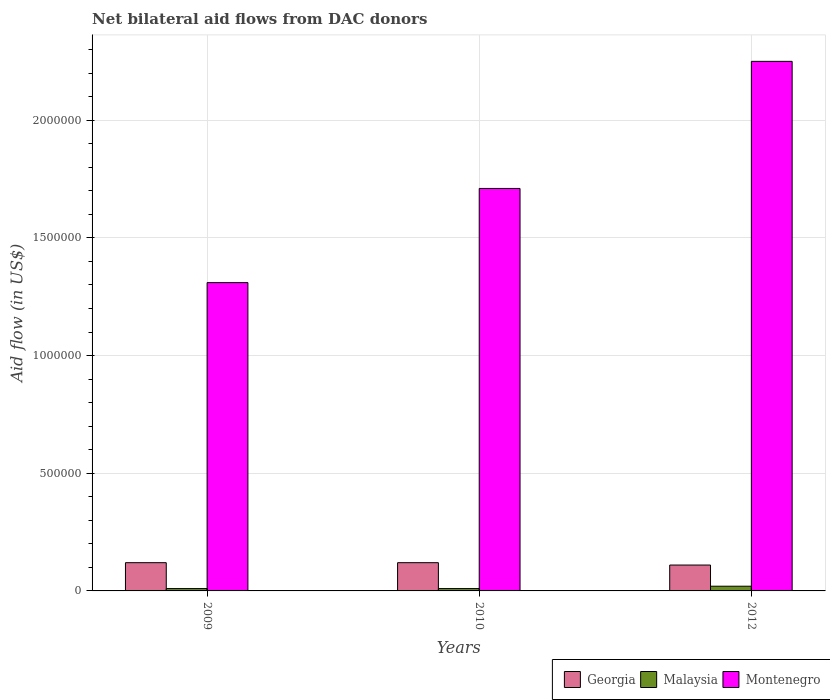How many different coloured bars are there?
Your answer should be very brief. 3. How many bars are there on the 3rd tick from the right?
Provide a succinct answer. 3. In how many cases, is the number of bars for a given year not equal to the number of legend labels?
Your response must be concise. 0. What is the net bilateral aid flow in Montenegro in 2009?
Your response must be concise. 1.31e+06. Across all years, what is the maximum net bilateral aid flow in Georgia?
Offer a very short reply. 1.20e+05. Across all years, what is the minimum net bilateral aid flow in Montenegro?
Your answer should be very brief. 1.31e+06. In which year was the net bilateral aid flow in Georgia maximum?
Offer a very short reply. 2009. In which year was the net bilateral aid flow in Georgia minimum?
Provide a succinct answer. 2012. What is the total net bilateral aid flow in Montenegro in the graph?
Provide a short and direct response. 5.27e+06. What is the difference between the net bilateral aid flow in Malaysia in 2009 and that in 2012?
Offer a terse response. -10000. What is the difference between the net bilateral aid flow in Georgia in 2010 and the net bilateral aid flow in Malaysia in 2012?
Provide a succinct answer. 1.00e+05. What is the average net bilateral aid flow in Malaysia per year?
Keep it short and to the point. 1.33e+04. In the year 2009, what is the difference between the net bilateral aid flow in Montenegro and net bilateral aid flow in Malaysia?
Your answer should be compact. 1.30e+06. In how many years, is the net bilateral aid flow in Georgia greater than 1200000 US$?
Offer a very short reply. 0. What is the ratio of the net bilateral aid flow in Malaysia in 2009 to that in 2012?
Your answer should be compact. 0.5. Is the difference between the net bilateral aid flow in Montenegro in 2009 and 2012 greater than the difference between the net bilateral aid flow in Malaysia in 2009 and 2012?
Your answer should be compact. No. What is the difference between the highest and the second highest net bilateral aid flow in Georgia?
Provide a succinct answer. 0. What is the difference between the highest and the lowest net bilateral aid flow in Georgia?
Provide a succinct answer. 10000. In how many years, is the net bilateral aid flow in Montenegro greater than the average net bilateral aid flow in Montenegro taken over all years?
Offer a terse response. 1. Is the sum of the net bilateral aid flow in Georgia in 2009 and 2012 greater than the maximum net bilateral aid flow in Malaysia across all years?
Keep it short and to the point. Yes. What does the 1st bar from the left in 2012 represents?
Offer a very short reply. Georgia. What does the 2nd bar from the right in 2010 represents?
Ensure brevity in your answer.  Malaysia. Is it the case that in every year, the sum of the net bilateral aid flow in Georgia and net bilateral aid flow in Montenegro is greater than the net bilateral aid flow in Malaysia?
Ensure brevity in your answer.  Yes. Are all the bars in the graph horizontal?
Give a very brief answer. No. Are the values on the major ticks of Y-axis written in scientific E-notation?
Keep it short and to the point. No. Does the graph contain any zero values?
Keep it short and to the point. No. Does the graph contain grids?
Your answer should be compact. Yes. Where does the legend appear in the graph?
Offer a very short reply. Bottom right. How are the legend labels stacked?
Keep it short and to the point. Horizontal. What is the title of the graph?
Offer a terse response. Net bilateral aid flows from DAC donors. Does "Europe(all income levels)" appear as one of the legend labels in the graph?
Offer a terse response. No. What is the label or title of the Y-axis?
Ensure brevity in your answer.  Aid flow (in US$). What is the Aid flow (in US$) in Malaysia in 2009?
Give a very brief answer. 10000. What is the Aid flow (in US$) in Montenegro in 2009?
Offer a terse response. 1.31e+06. What is the Aid flow (in US$) in Malaysia in 2010?
Give a very brief answer. 10000. What is the Aid flow (in US$) of Montenegro in 2010?
Provide a short and direct response. 1.71e+06. What is the Aid flow (in US$) in Montenegro in 2012?
Your response must be concise. 2.25e+06. Across all years, what is the maximum Aid flow (in US$) of Georgia?
Ensure brevity in your answer.  1.20e+05. Across all years, what is the maximum Aid flow (in US$) in Malaysia?
Your answer should be very brief. 2.00e+04. Across all years, what is the maximum Aid flow (in US$) of Montenegro?
Provide a succinct answer. 2.25e+06. Across all years, what is the minimum Aid flow (in US$) in Georgia?
Make the answer very short. 1.10e+05. Across all years, what is the minimum Aid flow (in US$) in Malaysia?
Your response must be concise. 10000. Across all years, what is the minimum Aid flow (in US$) of Montenegro?
Your answer should be very brief. 1.31e+06. What is the total Aid flow (in US$) in Montenegro in the graph?
Ensure brevity in your answer.  5.27e+06. What is the difference between the Aid flow (in US$) in Malaysia in 2009 and that in 2010?
Ensure brevity in your answer.  0. What is the difference between the Aid flow (in US$) in Montenegro in 2009 and that in 2010?
Your response must be concise. -4.00e+05. What is the difference between the Aid flow (in US$) of Georgia in 2009 and that in 2012?
Offer a terse response. 10000. What is the difference between the Aid flow (in US$) in Malaysia in 2009 and that in 2012?
Provide a succinct answer. -10000. What is the difference between the Aid flow (in US$) in Montenegro in 2009 and that in 2012?
Offer a terse response. -9.40e+05. What is the difference between the Aid flow (in US$) of Georgia in 2010 and that in 2012?
Ensure brevity in your answer.  10000. What is the difference between the Aid flow (in US$) in Montenegro in 2010 and that in 2012?
Keep it short and to the point. -5.40e+05. What is the difference between the Aid flow (in US$) of Georgia in 2009 and the Aid flow (in US$) of Malaysia in 2010?
Offer a very short reply. 1.10e+05. What is the difference between the Aid flow (in US$) in Georgia in 2009 and the Aid flow (in US$) in Montenegro in 2010?
Offer a very short reply. -1.59e+06. What is the difference between the Aid flow (in US$) in Malaysia in 2009 and the Aid flow (in US$) in Montenegro in 2010?
Offer a very short reply. -1.70e+06. What is the difference between the Aid flow (in US$) of Georgia in 2009 and the Aid flow (in US$) of Malaysia in 2012?
Ensure brevity in your answer.  1.00e+05. What is the difference between the Aid flow (in US$) of Georgia in 2009 and the Aid flow (in US$) of Montenegro in 2012?
Make the answer very short. -2.13e+06. What is the difference between the Aid flow (in US$) of Malaysia in 2009 and the Aid flow (in US$) of Montenegro in 2012?
Keep it short and to the point. -2.24e+06. What is the difference between the Aid flow (in US$) in Georgia in 2010 and the Aid flow (in US$) in Montenegro in 2012?
Your response must be concise. -2.13e+06. What is the difference between the Aid flow (in US$) of Malaysia in 2010 and the Aid flow (in US$) of Montenegro in 2012?
Offer a very short reply. -2.24e+06. What is the average Aid flow (in US$) in Georgia per year?
Offer a terse response. 1.17e+05. What is the average Aid flow (in US$) in Malaysia per year?
Your answer should be compact. 1.33e+04. What is the average Aid flow (in US$) of Montenegro per year?
Provide a short and direct response. 1.76e+06. In the year 2009, what is the difference between the Aid flow (in US$) in Georgia and Aid flow (in US$) in Montenegro?
Provide a succinct answer. -1.19e+06. In the year 2009, what is the difference between the Aid flow (in US$) of Malaysia and Aid flow (in US$) of Montenegro?
Offer a terse response. -1.30e+06. In the year 2010, what is the difference between the Aid flow (in US$) of Georgia and Aid flow (in US$) of Montenegro?
Make the answer very short. -1.59e+06. In the year 2010, what is the difference between the Aid flow (in US$) of Malaysia and Aid flow (in US$) of Montenegro?
Provide a succinct answer. -1.70e+06. In the year 2012, what is the difference between the Aid flow (in US$) in Georgia and Aid flow (in US$) in Montenegro?
Provide a succinct answer. -2.14e+06. In the year 2012, what is the difference between the Aid flow (in US$) of Malaysia and Aid flow (in US$) of Montenegro?
Offer a very short reply. -2.23e+06. What is the ratio of the Aid flow (in US$) of Malaysia in 2009 to that in 2010?
Give a very brief answer. 1. What is the ratio of the Aid flow (in US$) in Montenegro in 2009 to that in 2010?
Offer a very short reply. 0.77. What is the ratio of the Aid flow (in US$) of Georgia in 2009 to that in 2012?
Make the answer very short. 1.09. What is the ratio of the Aid flow (in US$) of Malaysia in 2009 to that in 2012?
Provide a succinct answer. 0.5. What is the ratio of the Aid flow (in US$) in Montenegro in 2009 to that in 2012?
Provide a succinct answer. 0.58. What is the ratio of the Aid flow (in US$) in Malaysia in 2010 to that in 2012?
Provide a succinct answer. 0.5. What is the ratio of the Aid flow (in US$) in Montenegro in 2010 to that in 2012?
Keep it short and to the point. 0.76. What is the difference between the highest and the second highest Aid flow (in US$) in Georgia?
Provide a short and direct response. 0. What is the difference between the highest and the second highest Aid flow (in US$) in Montenegro?
Your response must be concise. 5.40e+05. What is the difference between the highest and the lowest Aid flow (in US$) of Georgia?
Make the answer very short. 10000. What is the difference between the highest and the lowest Aid flow (in US$) in Malaysia?
Make the answer very short. 10000. What is the difference between the highest and the lowest Aid flow (in US$) in Montenegro?
Ensure brevity in your answer.  9.40e+05. 